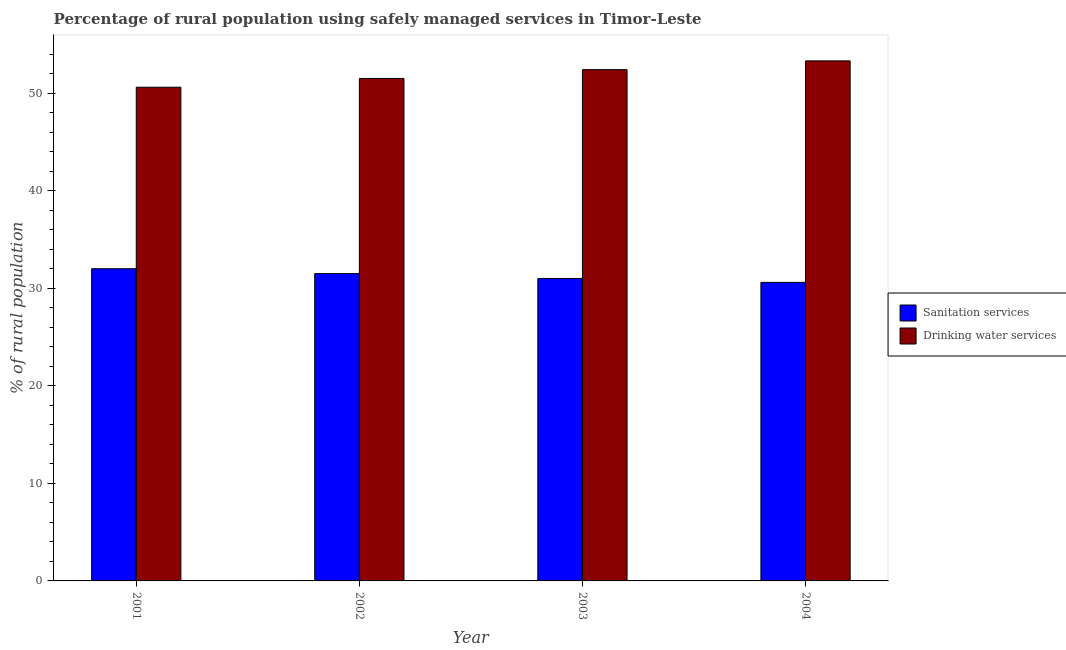How many different coloured bars are there?
Your answer should be very brief. 2. How many groups of bars are there?
Your response must be concise. 4. Are the number of bars per tick equal to the number of legend labels?
Keep it short and to the point. Yes. Are the number of bars on each tick of the X-axis equal?
Your answer should be compact. Yes. How many bars are there on the 2nd tick from the right?
Your response must be concise. 2. What is the percentage of rural population who used sanitation services in 2004?
Ensure brevity in your answer.  30.6. Across all years, what is the minimum percentage of rural population who used drinking water services?
Make the answer very short. 50.6. In which year was the percentage of rural population who used drinking water services maximum?
Your response must be concise. 2004. What is the total percentage of rural population who used drinking water services in the graph?
Offer a terse response. 207.8. What is the difference between the percentage of rural population who used drinking water services in 2003 and the percentage of rural population who used sanitation services in 2002?
Provide a succinct answer. 0.9. What is the average percentage of rural population who used drinking water services per year?
Make the answer very short. 51.95. In how many years, is the percentage of rural population who used sanitation services greater than 34 %?
Provide a short and direct response. 0. What is the ratio of the percentage of rural population who used drinking water services in 2002 to that in 2003?
Ensure brevity in your answer.  0.98. Is the percentage of rural population who used drinking water services in 2002 less than that in 2004?
Ensure brevity in your answer.  Yes. Is the difference between the percentage of rural population who used sanitation services in 2001 and 2003 greater than the difference between the percentage of rural population who used drinking water services in 2001 and 2003?
Ensure brevity in your answer.  No. What is the difference between the highest and the lowest percentage of rural population who used sanitation services?
Provide a short and direct response. 1.4. Is the sum of the percentage of rural population who used sanitation services in 2001 and 2004 greater than the maximum percentage of rural population who used drinking water services across all years?
Give a very brief answer. Yes. What does the 1st bar from the left in 2001 represents?
Your response must be concise. Sanitation services. What does the 1st bar from the right in 2002 represents?
Offer a terse response. Drinking water services. How many bars are there?
Provide a short and direct response. 8. Are all the bars in the graph horizontal?
Provide a short and direct response. No. What is the difference between two consecutive major ticks on the Y-axis?
Offer a terse response. 10. Does the graph contain any zero values?
Provide a succinct answer. No. Does the graph contain grids?
Make the answer very short. No. How are the legend labels stacked?
Provide a succinct answer. Vertical. What is the title of the graph?
Provide a short and direct response. Percentage of rural population using safely managed services in Timor-Leste. What is the label or title of the Y-axis?
Provide a short and direct response. % of rural population. What is the % of rural population of Sanitation services in 2001?
Provide a succinct answer. 32. What is the % of rural population of Drinking water services in 2001?
Your answer should be compact. 50.6. What is the % of rural population in Sanitation services in 2002?
Provide a short and direct response. 31.5. What is the % of rural population in Drinking water services in 2002?
Your response must be concise. 51.5. What is the % of rural population of Sanitation services in 2003?
Keep it short and to the point. 31. What is the % of rural population of Drinking water services in 2003?
Provide a succinct answer. 52.4. What is the % of rural population of Sanitation services in 2004?
Ensure brevity in your answer.  30.6. What is the % of rural population of Drinking water services in 2004?
Offer a very short reply. 53.3. Across all years, what is the maximum % of rural population of Drinking water services?
Make the answer very short. 53.3. Across all years, what is the minimum % of rural population of Sanitation services?
Your answer should be compact. 30.6. Across all years, what is the minimum % of rural population in Drinking water services?
Your response must be concise. 50.6. What is the total % of rural population of Sanitation services in the graph?
Ensure brevity in your answer.  125.1. What is the total % of rural population of Drinking water services in the graph?
Ensure brevity in your answer.  207.8. What is the difference between the % of rural population in Sanitation services in 2001 and that in 2002?
Provide a succinct answer. 0.5. What is the difference between the % of rural population in Sanitation services in 2001 and that in 2003?
Offer a terse response. 1. What is the difference between the % of rural population of Sanitation services in 2001 and that in 2004?
Make the answer very short. 1.4. What is the difference between the % of rural population in Drinking water services in 2001 and that in 2004?
Keep it short and to the point. -2.7. What is the difference between the % of rural population of Sanitation services in 2002 and that in 2003?
Your response must be concise. 0.5. What is the difference between the % of rural population of Drinking water services in 2002 and that in 2003?
Give a very brief answer. -0.9. What is the difference between the % of rural population in Drinking water services in 2002 and that in 2004?
Give a very brief answer. -1.8. What is the difference between the % of rural population in Sanitation services in 2001 and the % of rural population in Drinking water services in 2002?
Ensure brevity in your answer.  -19.5. What is the difference between the % of rural population of Sanitation services in 2001 and the % of rural population of Drinking water services in 2003?
Offer a terse response. -20.4. What is the difference between the % of rural population of Sanitation services in 2001 and the % of rural population of Drinking water services in 2004?
Keep it short and to the point. -21.3. What is the difference between the % of rural population in Sanitation services in 2002 and the % of rural population in Drinking water services in 2003?
Offer a very short reply. -20.9. What is the difference between the % of rural population in Sanitation services in 2002 and the % of rural population in Drinking water services in 2004?
Provide a short and direct response. -21.8. What is the difference between the % of rural population in Sanitation services in 2003 and the % of rural population in Drinking water services in 2004?
Your response must be concise. -22.3. What is the average % of rural population in Sanitation services per year?
Make the answer very short. 31.27. What is the average % of rural population of Drinking water services per year?
Your response must be concise. 51.95. In the year 2001, what is the difference between the % of rural population of Sanitation services and % of rural population of Drinking water services?
Give a very brief answer. -18.6. In the year 2003, what is the difference between the % of rural population in Sanitation services and % of rural population in Drinking water services?
Give a very brief answer. -21.4. In the year 2004, what is the difference between the % of rural population in Sanitation services and % of rural population in Drinking water services?
Provide a short and direct response. -22.7. What is the ratio of the % of rural population of Sanitation services in 2001 to that in 2002?
Your answer should be compact. 1.02. What is the ratio of the % of rural population of Drinking water services in 2001 to that in 2002?
Make the answer very short. 0.98. What is the ratio of the % of rural population in Sanitation services in 2001 to that in 2003?
Ensure brevity in your answer.  1.03. What is the ratio of the % of rural population of Drinking water services in 2001 to that in 2003?
Give a very brief answer. 0.97. What is the ratio of the % of rural population in Sanitation services in 2001 to that in 2004?
Keep it short and to the point. 1.05. What is the ratio of the % of rural population in Drinking water services in 2001 to that in 2004?
Give a very brief answer. 0.95. What is the ratio of the % of rural population of Sanitation services in 2002 to that in 2003?
Offer a terse response. 1.02. What is the ratio of the % of rural population of Drinking water services in 2002 to that in 2003?
Offer a very short reply. 0.98. What is the ratio of the % of rural population in Sanitation services in 2002 to that in 2004?
Provide a succinct answer. 1.03. What is the ratio of the % of rural population of Drinking water services in 2002 to that in 2004?
Provide a succinct answer. 0.97. What is the ratio of the % of rural population of Sanitation services in 2003 to that in 2004?
Offer a very short reply. 1.01. What is the ratio of the % of rural population in Drinking water services in 2003 to that in 2004?
Give a very brief answer. 0.98. What is the difference between the highest and the second highest % of rural population in Drinking water services?
Your answer should be compact. 0.9. What is the difference between the highest and the lowest % of rural population of Sanitation services?
Make the answer very short. 1.4. 